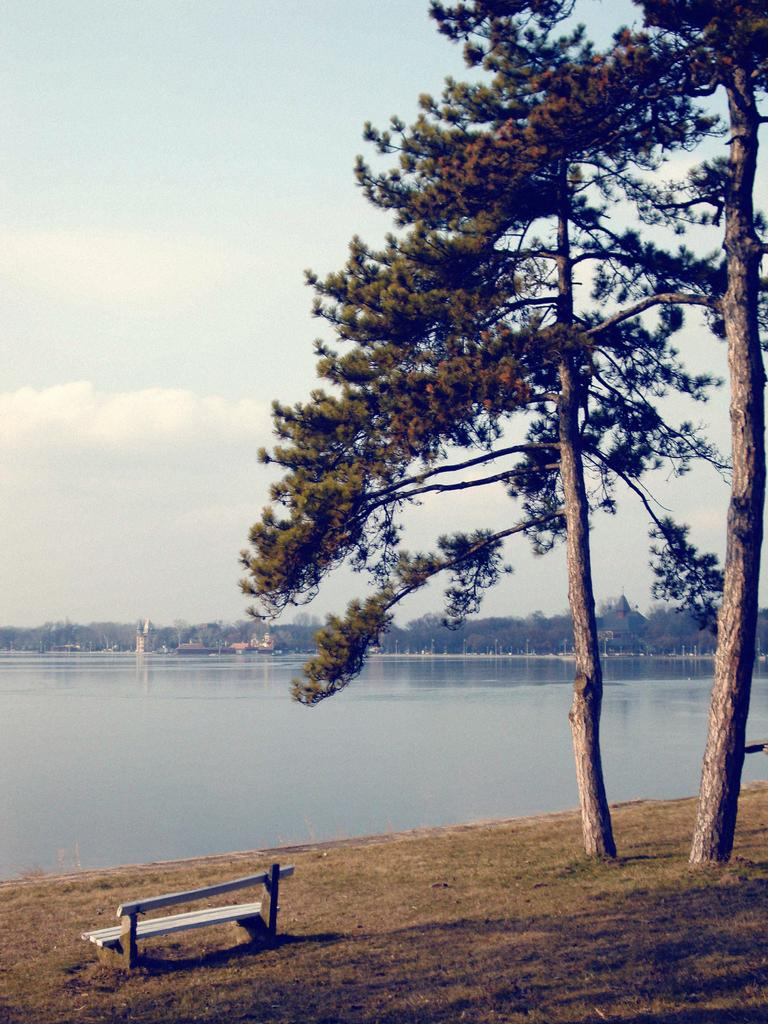What type of vegetation can be seen in the image? There are trees in the image. What type of seating is present on the ground in the image? There is a bench on the ground in the image. What can be seen in the background of the image? Water and the sky are visible in the background of the image. What type of pen is being used to write a story on the bench in the image? There is no pen or story being written on the bench in the image; it only features a bench and trees. Can you see any bones in the image? There are no bones present in the image. 